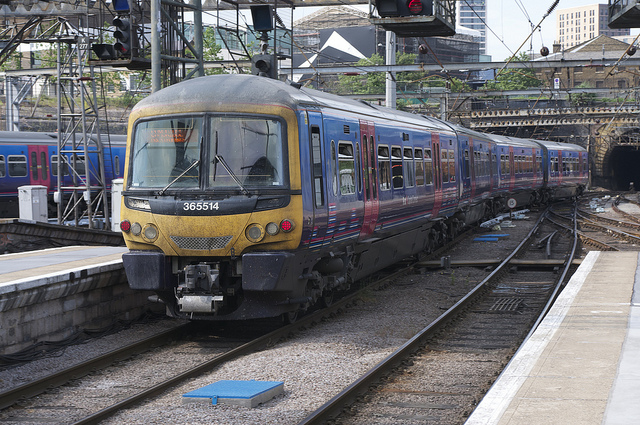Read all the text in this image. 365514 